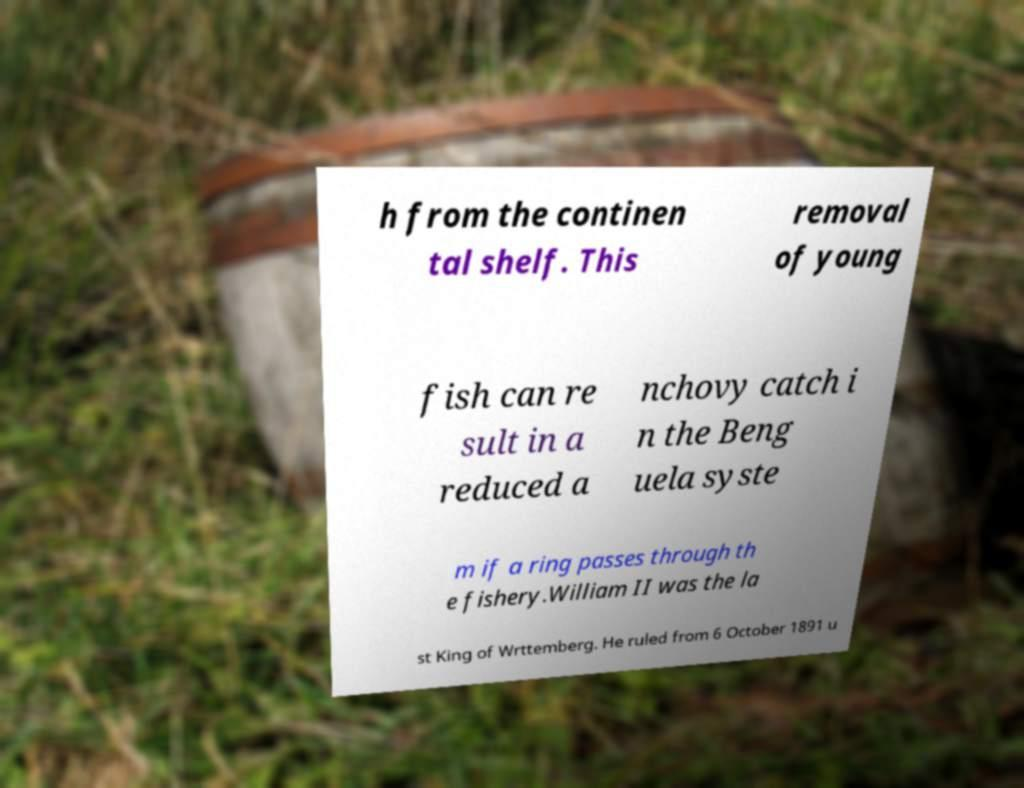I need the written content from this picture converted into text. Can you do that? h from the continen tal shelf. This removal of young fish can re sult in a reduced a nchovy catch i n the Beng uela syste m if a ring passes through th e fishery.William II was the la st King of Wrttemberg. He ruled from 6 October 1891 u 